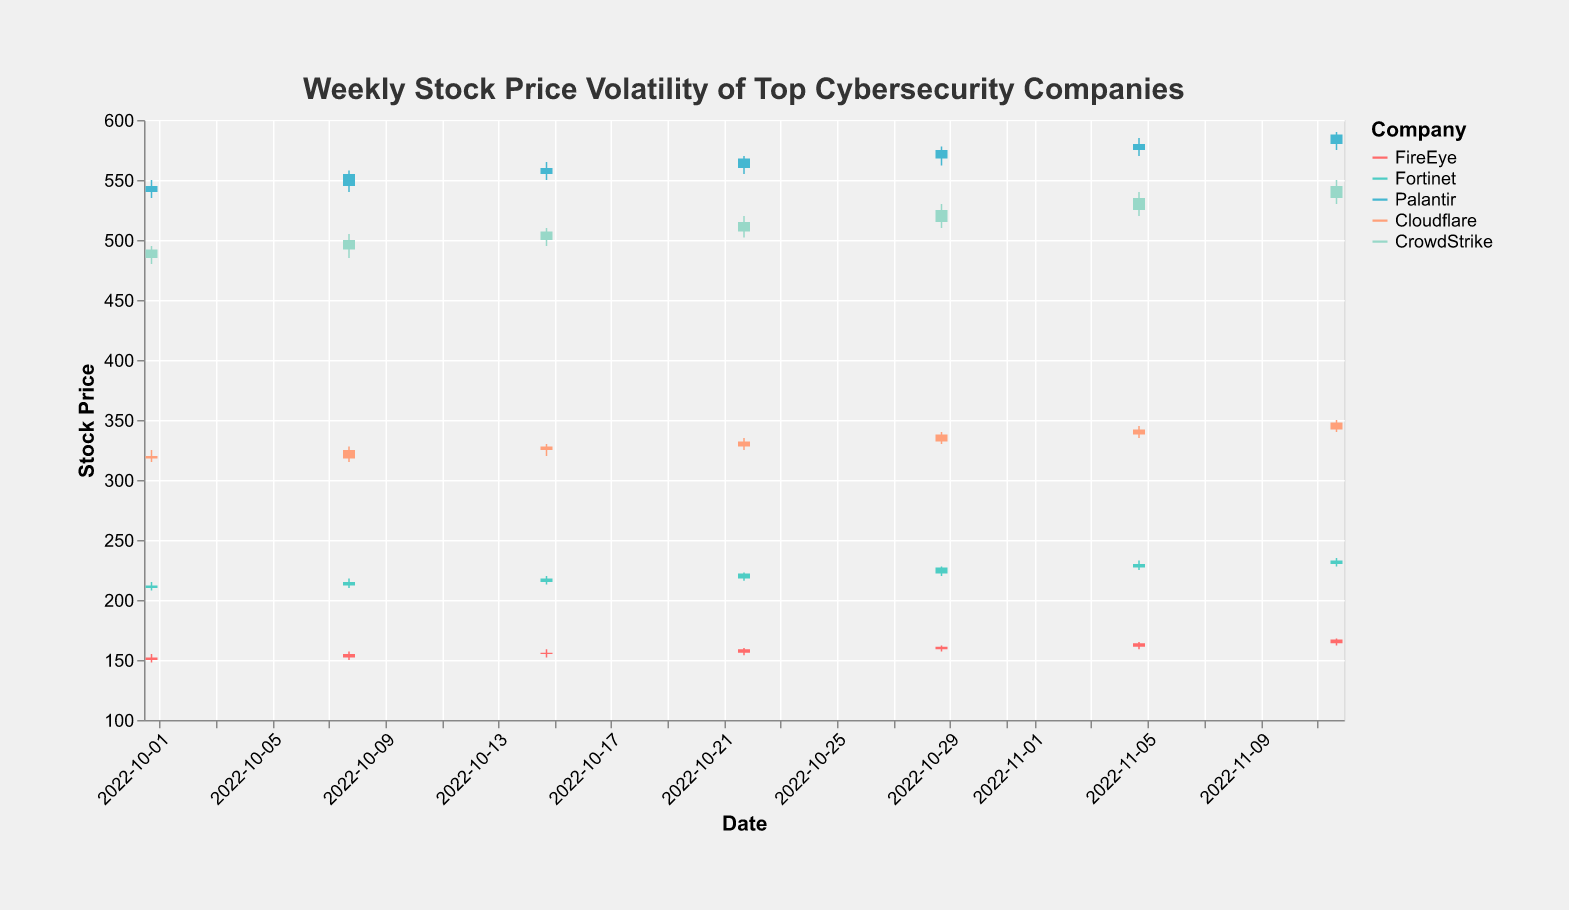What is the maximum stock price recorded for Palantir in the given data? Look at the candlestick plot for Palantir and identify the highest point on the y-axis representing price for Palantir. The highest recorded price for Palantir is 590.00 on 2022-11-12.
Answer: 590.00 Which company showed the highest closing price on 2022-11-05? Check the closing prices for all companies on 2022-11-05 in the candlestick plot. Palantir has the highest closing price of 580.00 on that date.
Answer: Palantir For Cloudflare, what was the price range (High-Low) on 2022-10-22? Find the high and low values for Cloudflare on 2022-10-22 in the plot. Subtract the low value from the high value. The high value is 335.00 and the low value is 325.00, so the range is 335.00 - 325.00 = 10.00.
Answer: 10.00 On which date did FireEye have the smallest difference between its opening and closing prices? Look at the candlestick plot bars for FireEye and identify the one with the smallest height, as this represents the smallest difference between opening and closing prices. The smallest difference is observed on 2022-10-15, where the opening and closing prices were 155.00 and 156.00, respectively.
Answer: 2022-10-15 Compare the stock price trend of Fortinet and Cloudflare from 2022-10-01 to 2022-11-12. Which company showed a more significant upward trend in its closing prices? To determine which company had a more significant upward trend, check the closing prices of both companies from 2022-10-01 to 2022-11-12. Fortinet's closing price increased from 212.00 to 233.00, a difference of 21.00, while Cloudflare's closing price increased from 318.00 to 348.00, a difference of 30.00. Hence, Cloudflare demonstrated a more significant upward trend.
Answer: Cloudflare 